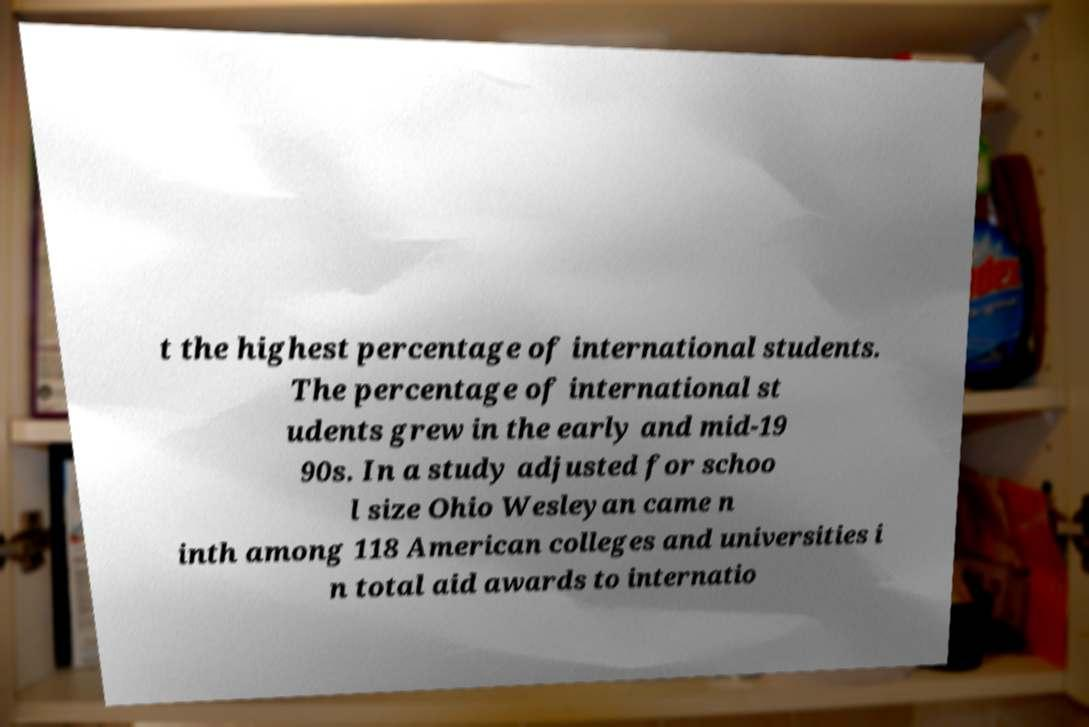Can you accurately transcribe the text from the provided image for me? t the highest percentage of international students. The percentage of international st udents grew in the early and mid-19 90s. In a study adjusted for schoo l size Ohio Wesleyan came n inth among 118 American colleges and universities i n total aid awards to internatio 